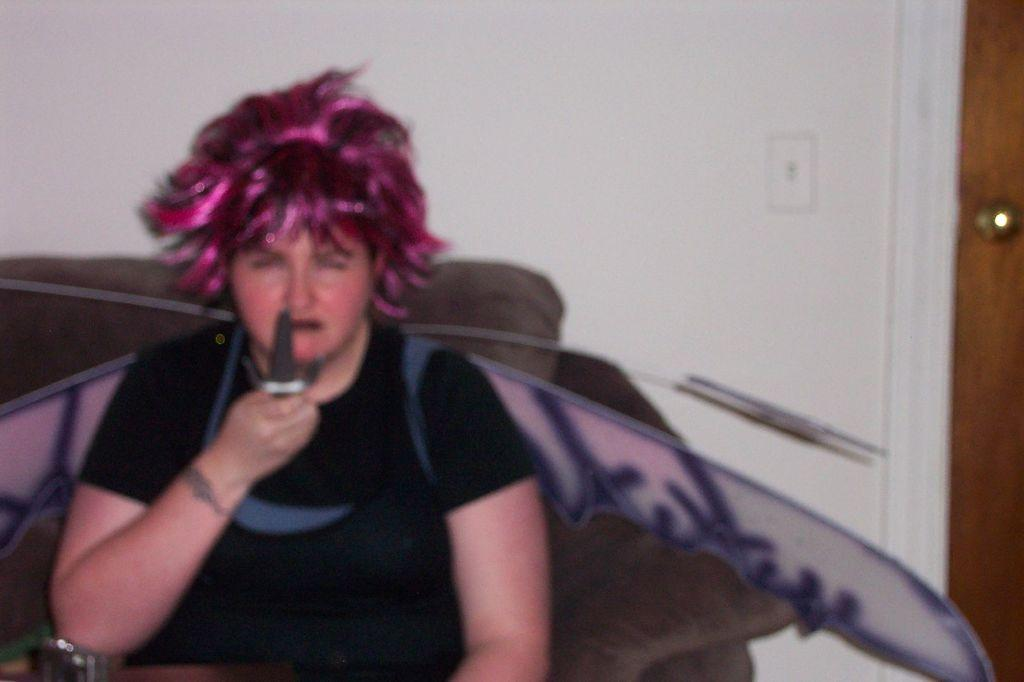Who is in the picture? There is a woman in the picture. What is the woman wearing? The woman is wearing a black dress. What is the woman doing in the picture? The woman is sitting. What is the woman holding in her hand? The woman is holding a knife in her hand. What can be seen in the right corner of the image? There is a door in the right corner of the image. What type of seed is being planted in the image? There is no seed or planting activity present in the image. What material is the brass used for in the image? There is no brass or any brass-related objects present in the image. 